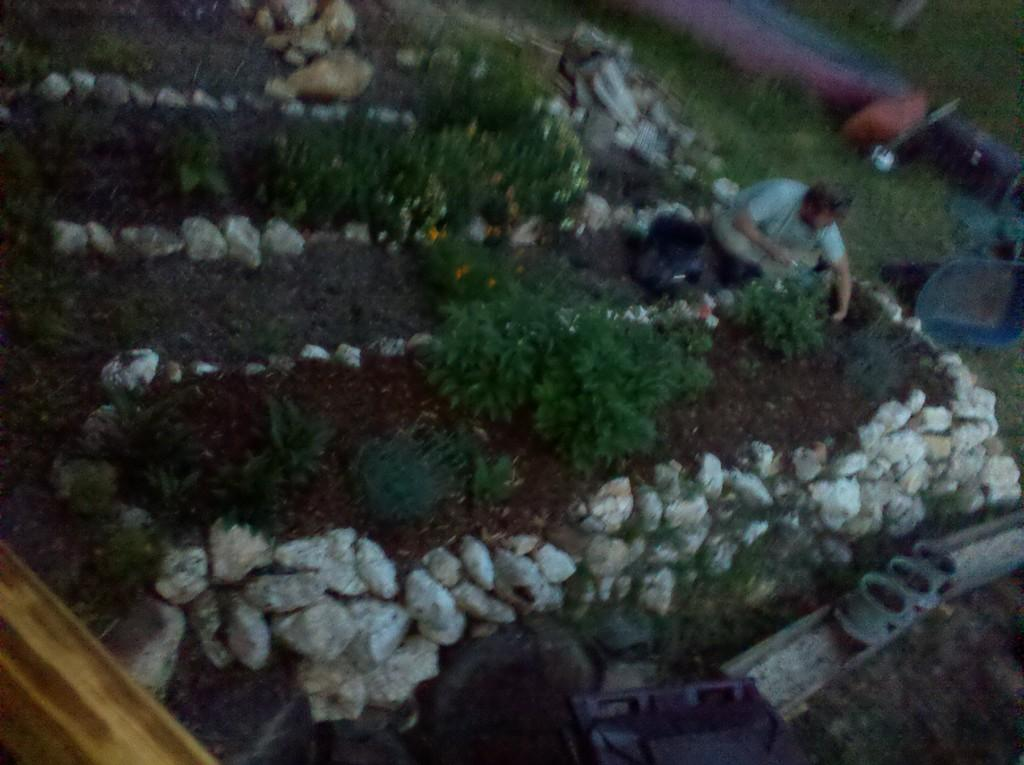Who or what is present in the image? There is a person in the image. What is the person wearing? The person is wearing clothes. What else can be seen in the image besides the person? There are plants in the image. Can you describe the location of the plants? The plants are located between rocks. What type of skirt is the snail wearing in the image? There is no snail or skirt present in the image. 